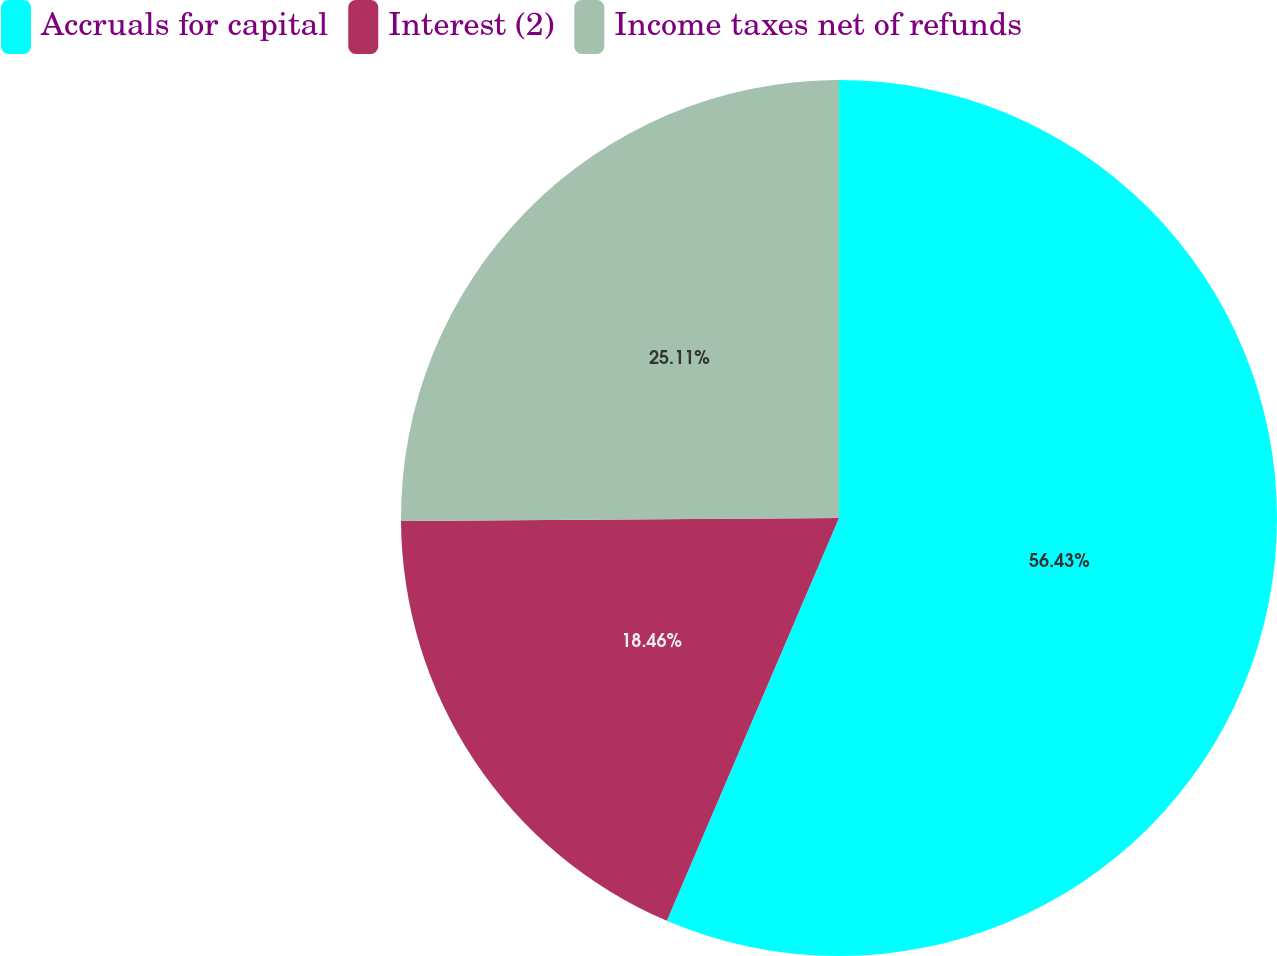<chart> <loc_0><loc_0><loc_500><loc_500><pie_chart><fcel>Accruals for capital<fcel>Interest (2)<fcel>Income taxes net of refunds<nl><fcel>56.43%<fcel>18.46%<fcel>25.11%<nl></chart> 